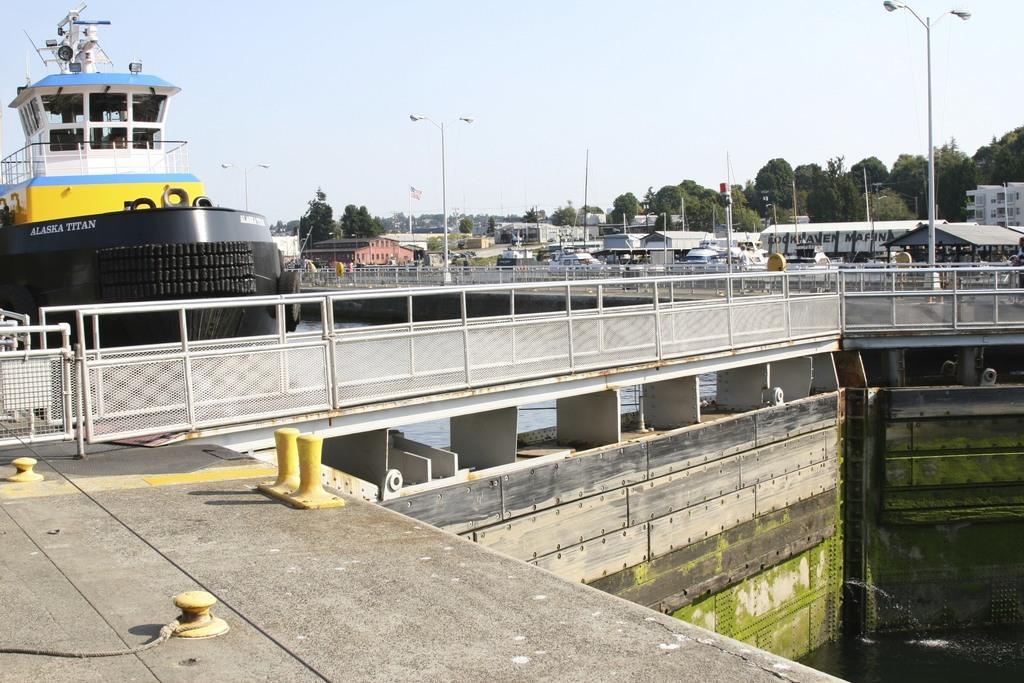Could you give a brief overview of what you see in this image? In this image we can see railings. And there are walls and small poles. Also there is water. And there is a ship. In the background there are railings. Also there are buildings. There are light poles. And there are trees and sky in the background. 